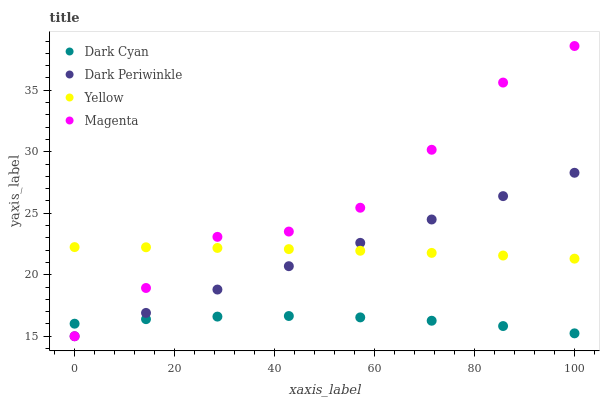Does Dark Cyan have the minimum area under the curve?
Answer yes or no. Yes. Does Magenta have the maximum area under the curve?
Answer yes or no. Yes. Does Dark Periwinkle have the minimum area under the curve?
Answer yes or no. No. Does Dark Periwinkle have the maximum area under the curve?
Answer yes or no. No. Is Dark Periwinkle the smoothest?
Answer yes or no. Yes. Is Magenta the roughest?
Answer yes or no. Yes. Is Magenta the smoothest?
Answer yes or no. No. Is Dark Periwinkle the roughest?
Answer yes or no. No. Does Magenta have the lowest value?
Answer yes or no. Yes. Does Yellow have the lowest value?
Answer yes or no. No. Does Magenta have the highest value?
Answer yes or no. Yes. Does Dark Periwinkle have the highest value?
Answer yes or no. No. Is Dark Cyan less than Yellow?
Answer yes or no. Yes. Is Yellow greater than Dark Cyan?
Answer yes or no. Yes. Does Dark Cyan intersect Magenta?
Answer yes or no. Yes. Is Dark Cyan less than Magenta?
Answer yes or no. No. Is Dark Cyan greater than Magenta?
Answer yes or no. No. Does Dark Cyan intersect Yellow?
Answer yes or no. No. 